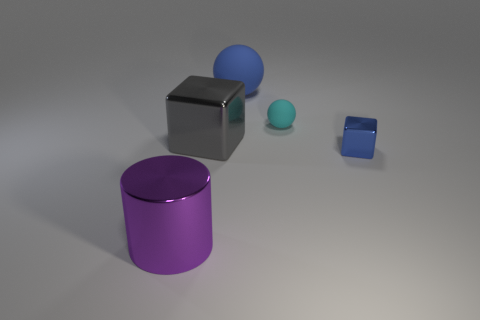Are there fewer small cyan things than big things?
Offer a terse response. Yes. Does the sphere that is in front of the blue sphere have the same material as the blue object in front of the big rubber thing?
Provide a short and direct response. No. What is the shape of the matte object behind the tiny thing that is on the left side of the blue object to the right of the small cyan matte object?
Ensure brevity in your answer.  Sphere. How many purple cylinders have the same material as the tiny sphere?
Offer a terse response. 0. How many blue objects are behind the large shiny thing that is on the right side of the shiny cylinder?
Your answer should be very brief. 1. Does the sphere on the left side of the small rubber sphere have the same color as the metal block right of the small cyan ball?
Ensure brevity in your answer.  Yes. What is the shape of the object that is to the right of the purple cylinder and on the left side of the big matte ball?
Ensure brevity in your answer.  Cube. Is there another purple thing of the same shape as the purple thing?
Provide a short and direct response. No. What shape is the gray thing that is the same size as the blue ball?
Offer a very short reply. Cube. What is the material of the small blue block?
Ensure brevity in your answer.  Metal. 